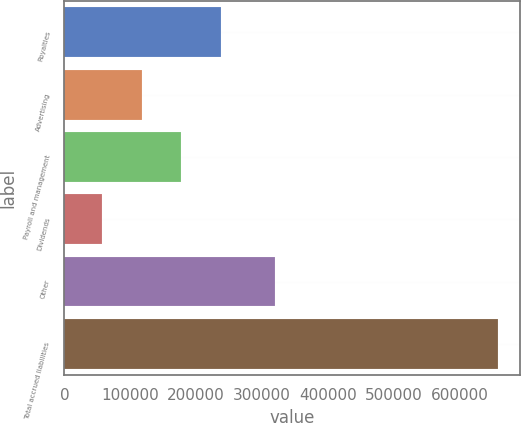Convert chart to OTSL. <chart><loc_0><loc_0><loc_500><loc_500><bar_chart><fcel>Royalties<fcel>Advertising<fcel>Payroll and management<fcel>Dividends<fcel>Other<fcel>Total accrued liabilities<nl><fcel>237846<fcel>117553<fcel>177700<fcel>57406<fcel>320137<fcel>658874<nl></chart> 